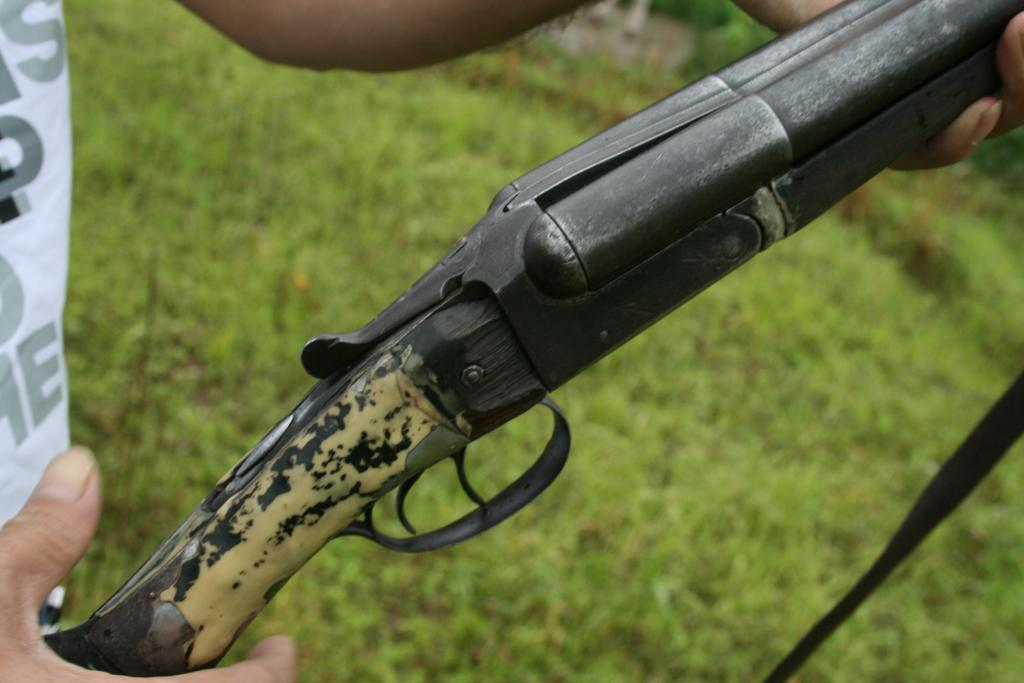What can be seen in the image? There is a person in the image. What is the person holding? The person is holding a gun. What type of environment is depicted in the image? There is grass visible in the image, suggesting an outdoor setting. How many boots can be seen on the person's wrist in the image? There are no boots visible on the person's wrist in the image. 